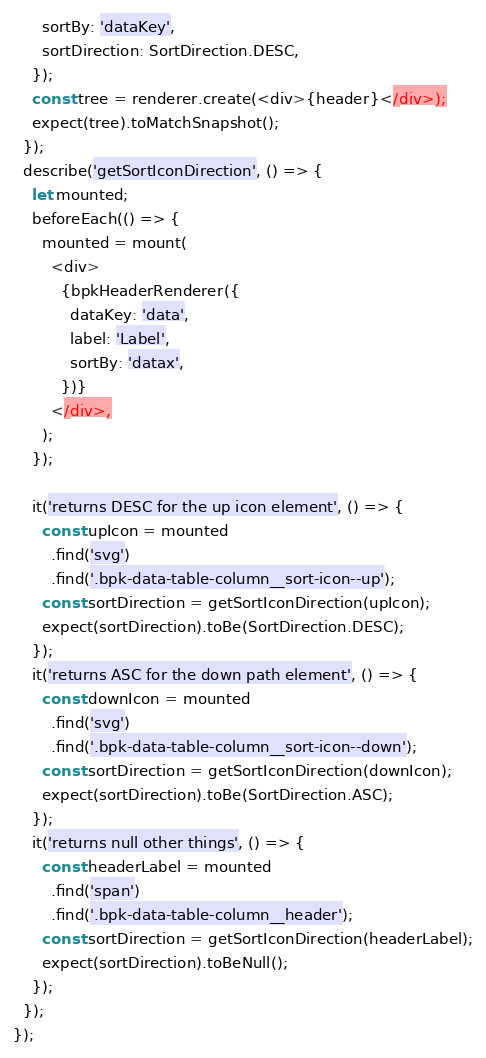Convert code to text. <code><loc_0><loc_0><loc_500><loc_500><_JavaScript_>      sortBy: 'dataKey',
      sortDirection: SortDirection.DESC,
    });
    const tree = renderer.create(<div>{header}</div>);
    expect(tree).toMatchSnapshot();
  });
  describe('getSortIconDirection', () => {
    let mounted;
    beforeEach(() => {
      mounted = mount(
        <div>
          {bpkHeaderRenderer({
            dataKey: 'data',
            label: 'Label',
            sortBy: 'datax',
          })}
        </div>,
      );
    });

    it('returns DESC for the up icon element', () => {
      const upIcon = mounted
        .find('svg')
        .find('.bpk-data-table-column__sort-icon--up');
      const sortDirection = getSortIconDirection(upIcon);
      expect(sortDirection).toBe(SortDirection.DESC);
    });
    it('returns ASC for the down path element', () => {
      const downIcon = mounted
        .find('svg')
        .find('.bpk-data-table-column__sort-icon--down');
      const sortDirection = getSortIconDirection(downIcon);
      expect(sortDirection).toBe(SortDirection.ASC);
    });
    it('returns null other things', () => {
      const headerLabel = mounted
        .find('span')
        .find('.bpk-data-table-column__header');
      const sortDirection = getSortIconDirection(headerLabel);
      expect(sortDirection).toBeNull();
    });
  });
});
</code> 